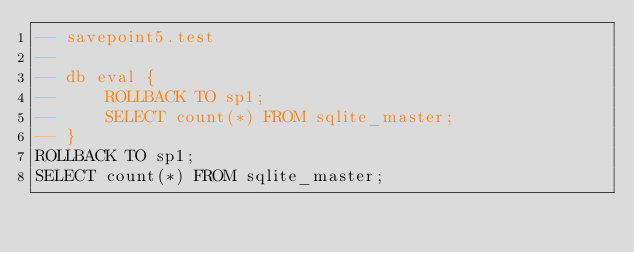<code> <loc_0><loc_0><loc_500><loc_500><_SQL_>-- savepoint5.test
-- 
-- db eval {
--     ROLLBACK TO sp1;
--     SELECT count(*) FROM sqlite_master;
-- }
ROLLBACK TO sp1;
SELECT count(*) FROM sqlite_master;</code> 